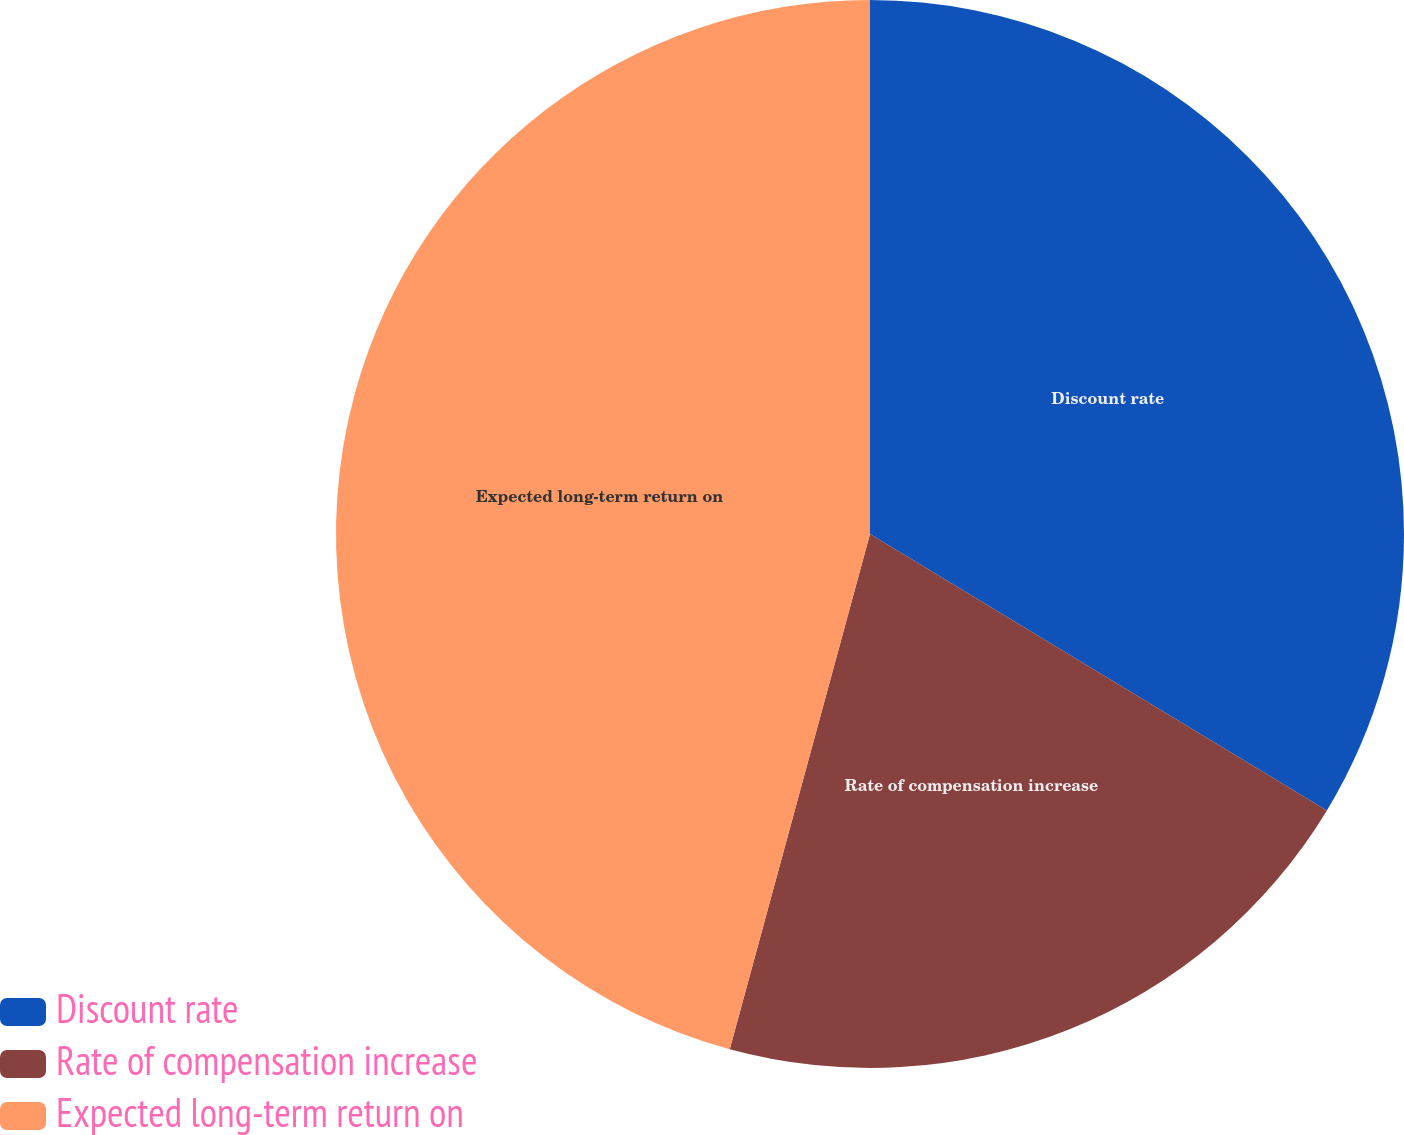Convert chart to OTSL. <chart><loc_0><loc_0><loc_500><loc_500><pie_chart><fcel>Discount rate<fcel>Rate of compensation increase<fcel>Expected long-term return on<nl><fcel>33.66%<fcel>20.57%<fcel>45.77%<nl></chart> 